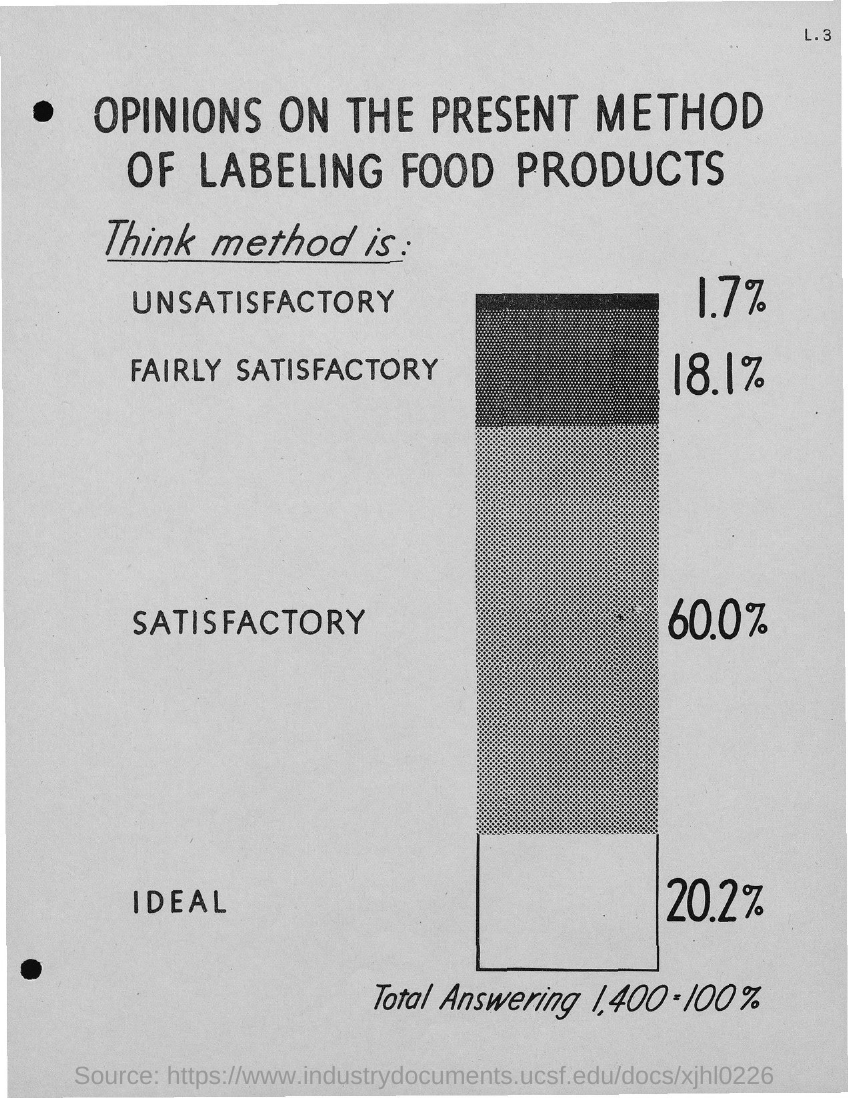What percent of opinions on the present method of labeling food products is unsatisfactory?
Your answer should be very brief. 1.7%. What percent of opinions on the present method of labeling food products is fairly satisfactory?
Your response must be concise. 18.1%. What percent of opinions on the present method of labeling food products is satisfactory?
Your response must be concise. 60.0%. What percent of opinions on the present method of labeling food products is ideal?
Your answer should be compact. 20.2%. 